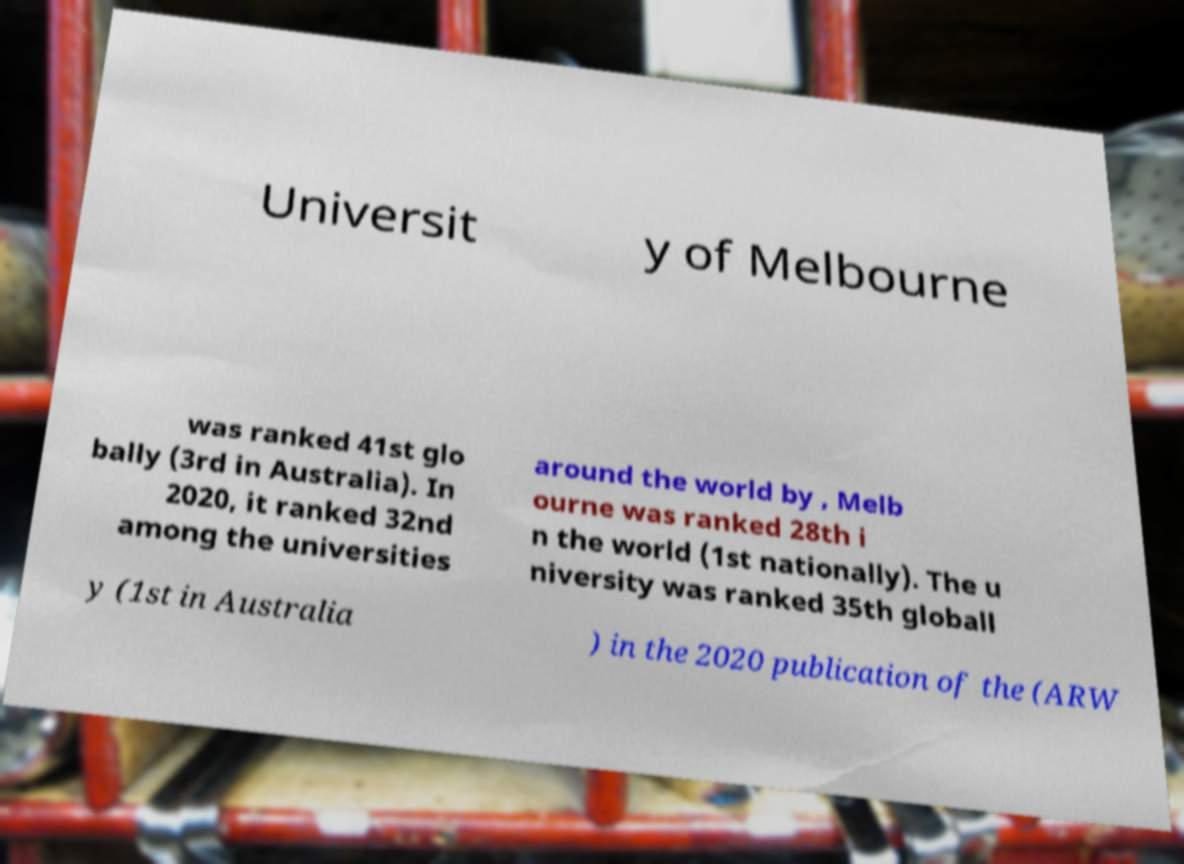Could you assist in decoding the text presented in this image and type it out clearly? Universit y of Melbourne was ranked 41st glo bally (3rd in Australia). In 2020, it ranked 32nd among the universities around the world by , Melb ourne was ranked 28th i n the world (1st nationally). The u niversity was ranked 35th globall y (1st in Australia ) in the 2020 publication of the (ARW 